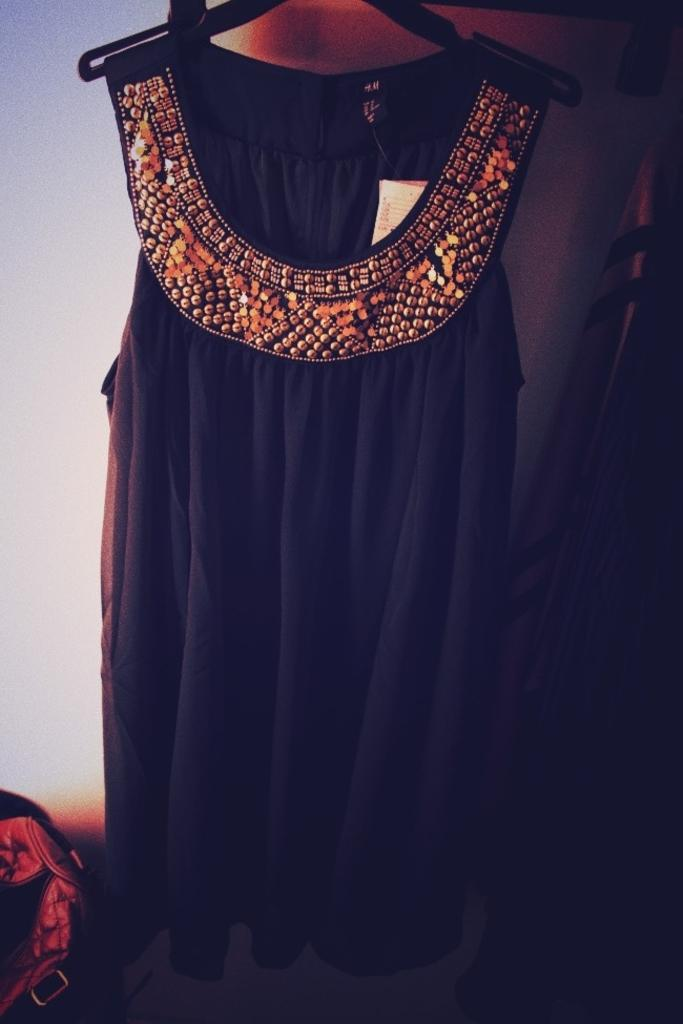What is the main subject in the middle of the image? There is a dress in the middle of the image. What else can be seen on the left side of the image? There appears to be a bag on the left side of the image. How does the baby react to the punishment in the image? There is no baby or punishment present in the image. 